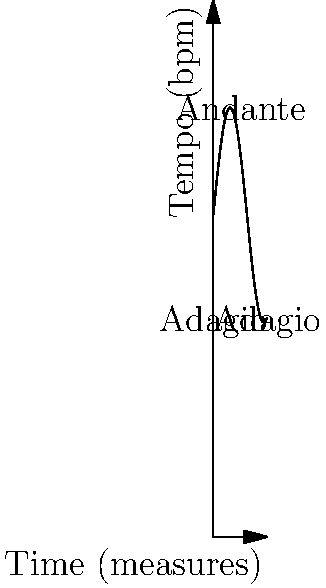In the given baroque musical score excerpt, the tempo marking changes from Adagio to Andante and back to Adagio. Approximately how many measures does it take for the tempo to reach its peak (Andante)? To answer this question, we need to analyze the graph:

1. The x-axis represents time in measures, while the y-axis shows tempo in beats per minute (bpm).
2. The curve represents the change in tempo over time.
3. We can see that the tempo starts at Adagio (slower tempo), increases to Andante (moderate tempo), and then returns to Adagio.
4. The peak of the curve represents the fastest tempo, which is Andante in this case.
5. To find where the tempo reaches its peak, we need to locate the highest point on the curve.
6. By examining the graph, we can see that the highest point occurs at approximately 5 measures.

Therefore, it takes about 5 measures for the tempo to reach its peak (Andante) from the initial Adagio.
Answer: 5 measures 